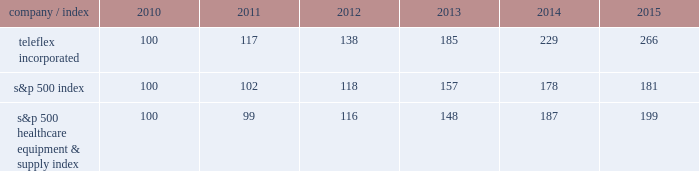Stock performance graph the following graph provides a comparison of five year cumulative total stockholder returns of teleflex common stock , the standard & poor 2019s ( s&p ) 500 stock index and the s&p 500 healthcare equipment & supply index .
The annual changes for the five-year period shown on the graph are based on the assumption that $ 100 had been invested in teleflex common stock and each index on december 31 , 2010 and that all dividends were reinvested .
Market performance .
S&p 500 healthcare equipment & supply index 100 99 116 148 187 199 .
What is the total return of an investment of $ 1000000 in s&p 500 index in 2010 and sold in 2015? 
Computations: ((1000000 / 100) * (181 - 100))
Answer: 810000.0. 